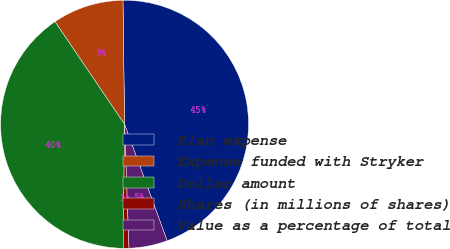<chart> <loc_0><loc_0><loc_500><loc_500><pie_chart><fcel>Plan expense<fcel>Expense funded with Stryker<fcel>Dollar amount<fcel>Shares (in millions of shares)<fcel>Value as a percentage of total<nl><fcel>44.62%<fcel>9.28%<fcel>40.35%<fcel>0.74%<fcel>5.01%<nl></chart> 